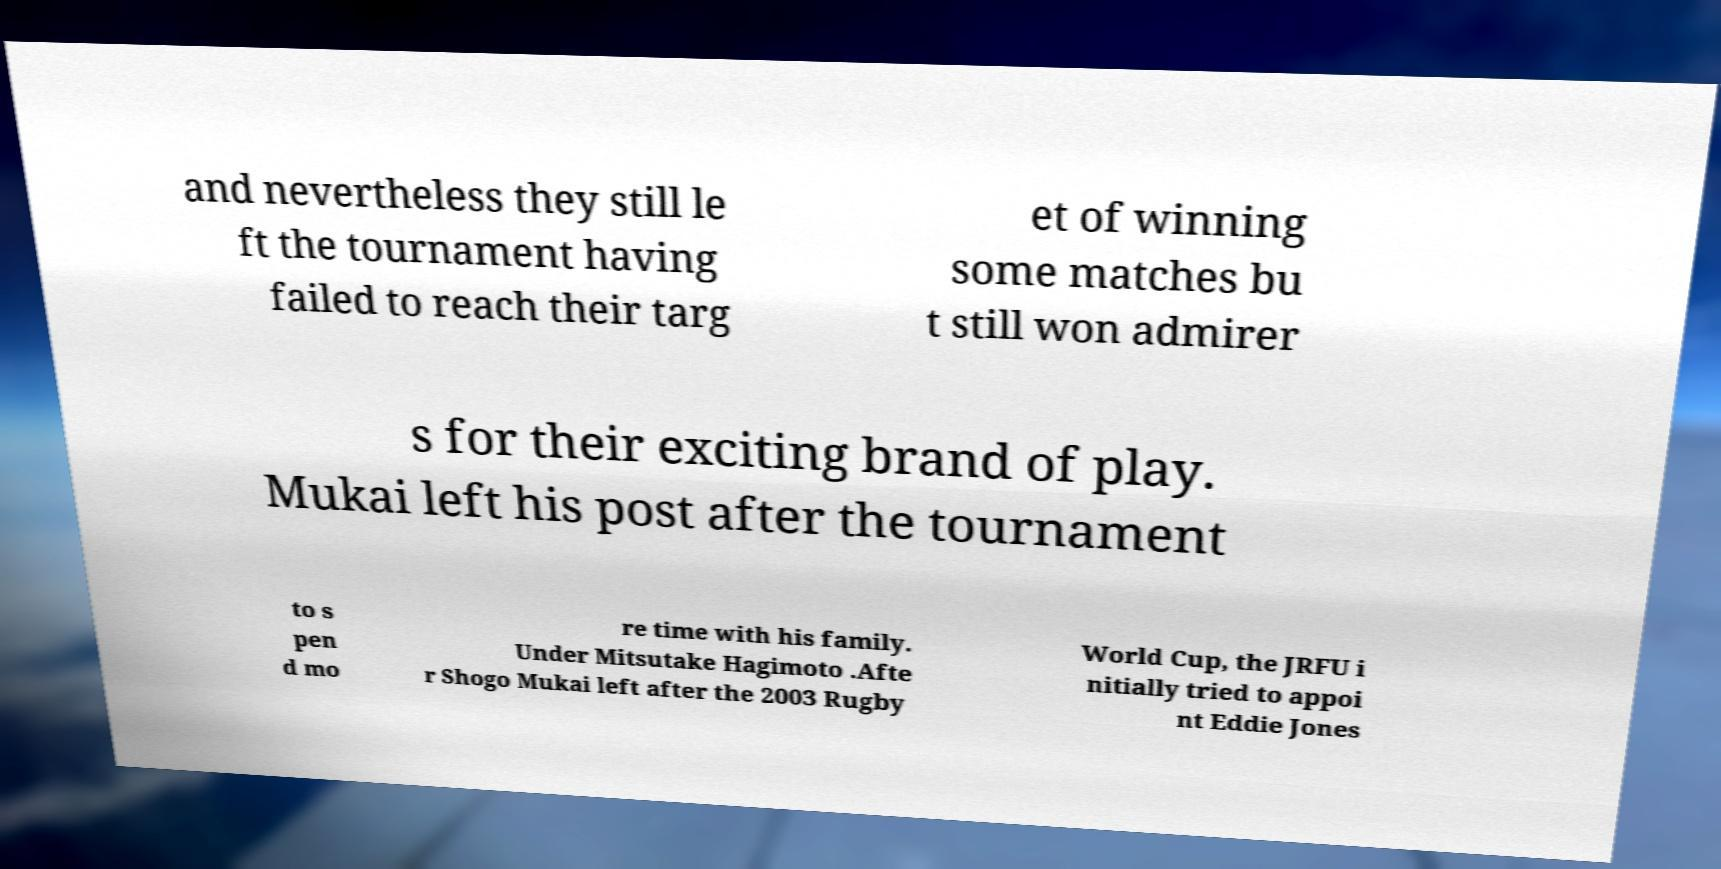I need the written content from this picture converted into text. Can you do that? and nevertheless they still le ft the tournament having failed to reach their targ et of winning some matches bu t still won admirer s for their exciting brand of play. Mukai left his post after the tournament to s pen d mo re time with his family. Under Mitsutake Hagimoto .Afte r Shogo Mukai left after the 2003 Rugby World Cup, the JRFU i nitially tried to appoi nt Eddie Jones 